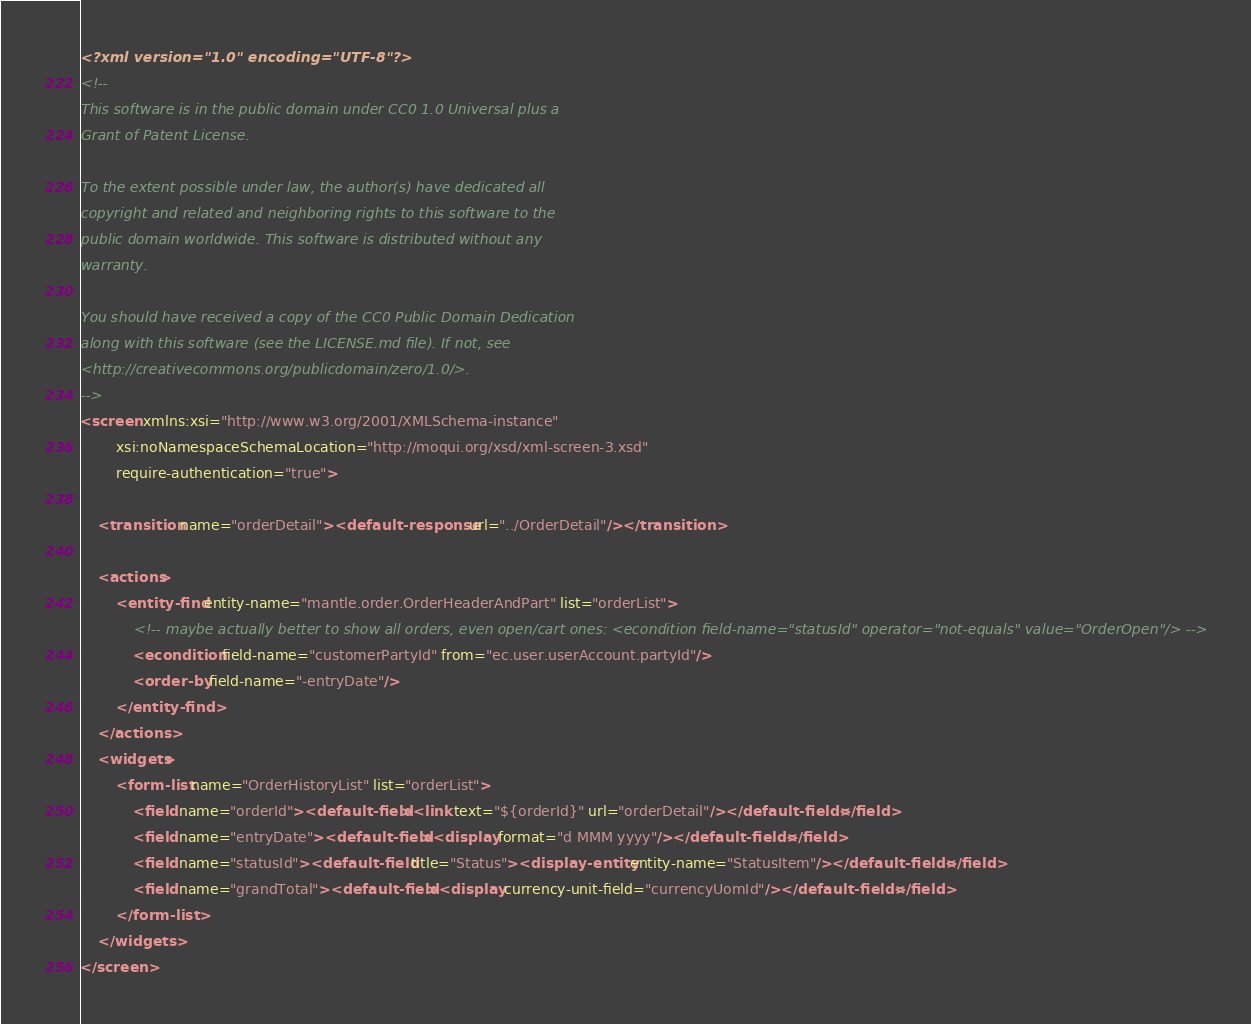<code> <loc_0><loc_0><loc_500><loc_500><_XML_><?xml version="1.0" encoding="UTF-8"?>
<!--
This software is in the public domain under CC0 1.0 Universal plus a 
Grant of Patent License.

To the extent possible under law, the author(s) have dedicated all
copyright and related and neighboring rights to this software to the
public domain worldwide. This software is distributed without any
warranty.

You should have received a copy of the CC0 Public Domain Dedication
along with this software (see the LICENSE.md file). If not, see
<http://creativecommons.org/publicdomain/zero/1.0/>.
-->
<screen xmlns:xsi="http://www.w3.org/2001/XMLSchema-instance"
        xsi:noNamespaceSchemaLocation="http://moqui.org/xsd/xml-screen-3.xsd"
        require-authentication="true">

    <transition name="orderDetail"><default-response url="../OrderDetail"/></transition>

    <actions>
        <entity-find entity-name="mantle.order.OrderHeaderAndPart" list="orderList">
            <!-- maybe actually better to show all orders, even open/cart ones: <econdition field-name="statusId" operator="not-equals" value="OrderOpen"/> -->
            <econdition field-name="customerPartyId" from="ec.user.userAccount.partyId"/>
            <order-by field-name="-entryDate"/>
        </entity-find>
    </actions>
    <widgets>
        <form-list name="OrderHistoryList" list="orderList">
            <field name="orderId"><default-field><link text="${orderId}" url="orderDetail"/></default-field></field>
            <field name="entryDate"><default-field><display format="d MMM yyyy"/></default-field></field>
            <field name="statusId"><default-field title="Status"><display-entity entity-name="StatusItem"/></default-field></field>
            <field name="grandTotal"><default-field><display currency-unit-field="currencyUomId"/></default-field></field>
        </form-list>
    </widgets>
</screen>
</code> 